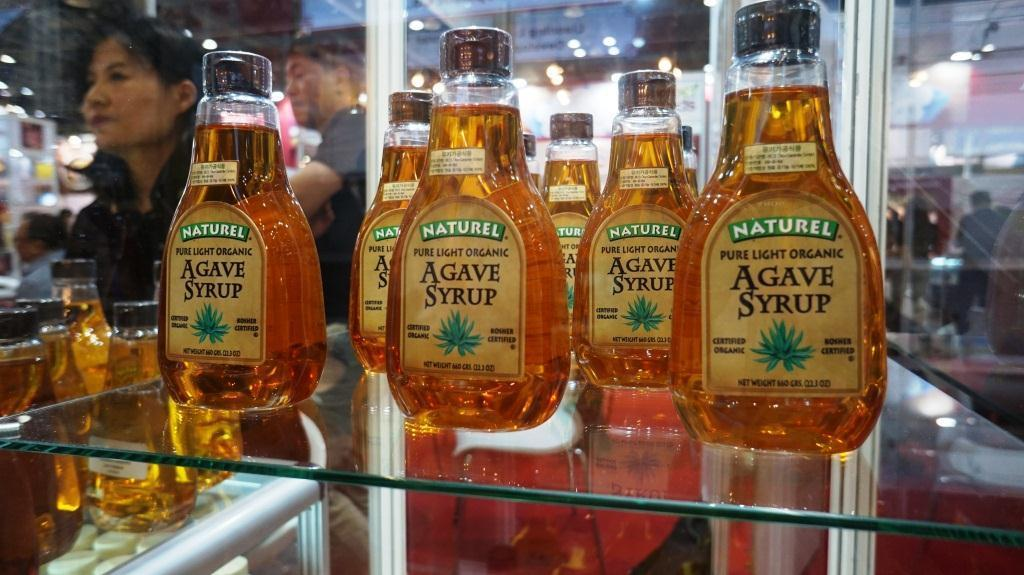<image>
Render a clear and concise summary of the photo. A few bottles of Naturel Agave Syrup on a glass shelf. 